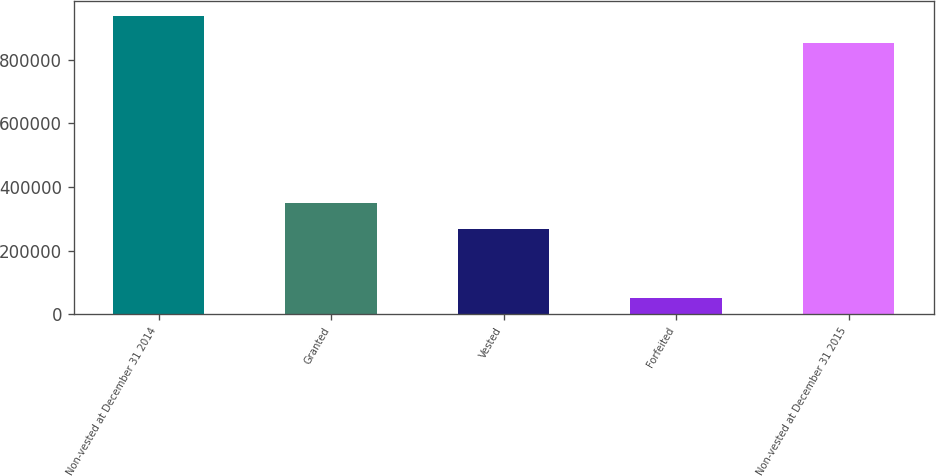<chart> <loc_0><loc_0><loc_500><loc_500><bar_chart><fcel>Non-vested at December 31 2014<fcel>Granted<fcel>Vested<fcel>Forfeited<fcel>Non-vested at December 31 2015<nl><fcel>936384<fcel>349810<fcel>266683<fcel>49252<fcel>853257<nl></chart> 